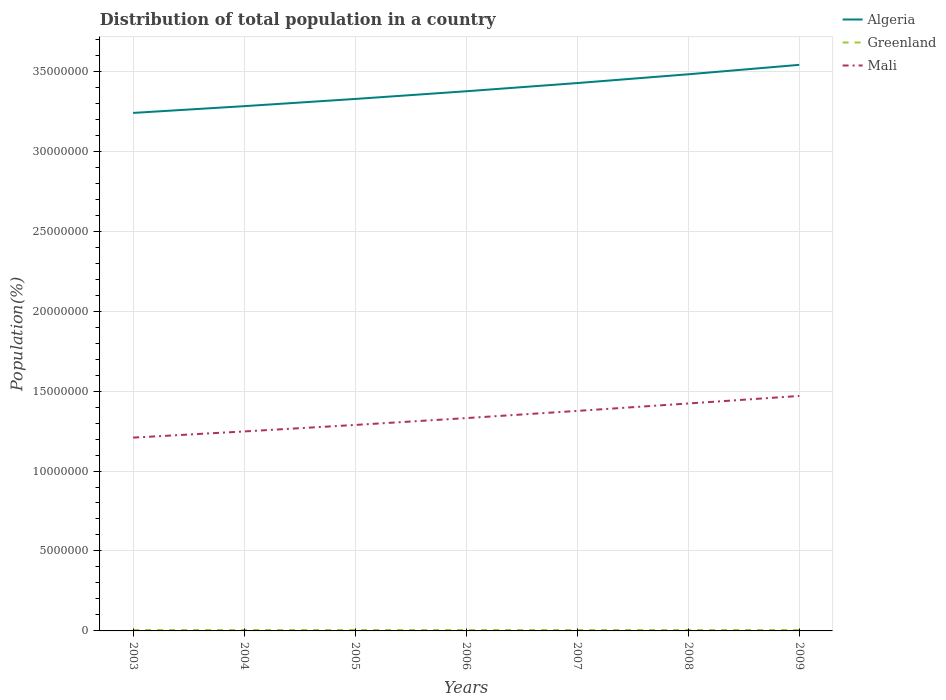How many different coloured lines are there?
Make the answer very short. 3. Is the number of lines equal to the number of legend labels?
Offer a terse response. Yes. Across all years, what is the maximum population of in Mali?
Ensure brevity in your answer.  1.21e+07. What is the total population of in Algeria in the graph?
Give a very brief answer. -1.35e+06. What is the difference between the highest and the second highest population of in Algeria?
Ensure brevity in your answer.  3.01e+06. What is the difference between the highest and the lowest population of in Greenland?
Make the answer very short. 4. How many lines are there?
Ensure brevity in your answer.  3. Are the values on the major ticks of Y-axis written in scientific E-notation?
Provide a succinct answer. No. Does the graph contain any zero values?
Offer a very short reply. No. Does the graph contain grids?
Give a very brief answer. Yes. Where does the legend appear in the graph?
Offer a very short reply. Top right. How are the legend labels stacked?
Your answer should be compact. Vertical. What is the title of the graph?
Make the answer very short. Distribution of total population in a country. What is the label or title of the X-axis?
Provide a succinct answer. Years. What is the label or title of the Y-axis?
Your answer should be very brief. Population(%). What is the Population(%) in Algeria in 2003?
Your answer should be compact. 3.24e+07. What is the Population(%) of Greenland in 2003?
Ensure brevity in your answer.  5.68e+04. What is the Population(%) in Mali in 2003?
Your answer should be very brief. 1.21e+07. What is the Population(%) in Algeria in 2004?
Keep it short and to the point. 3.28e+07. What is the Population(%) in Greenland in 2004?
Your response must be concise. 5.69e+04. What is the Population(%) of Mali in 2004?
Make the answer very short. 1.25e+07. What is the Population(%) of Algeria in 2005?
Provide a short and direct response. 3.33e+07. What is the Population(%) of Greenland in 2005?
Your answer should be compact. 5.69e+04. What is the Population(%) of Mali in 2005?
Offer a very short reply. 1.29e+07. What is the Population(%) in Algeria in 2006?
Make the answer very short. 3.37e+07. What is the Population(%) in Greenland in 2006?
Offer a very short reply. 5.68e+04. What is the Population(%) in Mali in 2006?
Give a very brief answer. 1.33e+07. What is the Population(%) of Algeria in 2007?
Give a very brief answer. 3.43e+07. What is the Population(%) of Greenland in 2007?
Provide a short and direct response. 5.66e+04. What is the Population(%) in Mali in 2007?
Provide a succinct answer. 1.38e+07. What is the Population(%) of Algeria in 2008?
Your answer should be compact. 3.48e+07. What is the Population(%) of Greenland in 2008?
Offer a very short reply. 5.63e+04. What is the Population(%) in Mali in 2008?
Your response must be concise. 1.42e+07. What is the Population(%) of Algeria in 2009?
Offer a terse response. 3.54e+07. What is the Population(%) of Greenland in 2009?
Your answer should be compact. 5.63e+04. What is the Population(%) in Mali in 2009?
Your answer should be very brief. 1.47e+07. Across all years, what is the maximum Population(%) of Algeria?
Your response must be concise. 3.54e+07. Across all years, what is the maximum Population(%) in Greenland?
Give a very brief answer. 5.69e+04. Across all years, what is the maximum Population(%) of Mali?
Give a very brief answer. 1.47e+07. Across all years, what is the minimum Population(%) in Algeria?
Offer a very short reply. 3.24e+07. Across all years, what is the minimum Population(%) in Greenland?
Keep it short and to the point. 5.63e+04. Across all years, what is the minimum Population(%) in Mali?
Keep it short and to the point. 1.21e+07. What is the total Population(%) in Algeria in the graph?
Your response must be concise. 2.37e+08. What is the total Population(%) in Greenland in the graph?
Make the answer very short. 3.97e+05. What is the total Population(%) of Mali in the graph?
Your answer should be very brief. 9.34e+07. What is the difference between the Population(%) in Algeria in 2003 and that in 2004?
Your response must be concise. -4.22e+05. What is the difference between the Population(%) of Greenland in 2003 and that in 2004?
Ensure brevity in your answer.  -146. What is the difference between the Population(%) of Mali in 2003 and that in 2004?
Your answer should be very brief. -3.86e+05. What is the difference between the Population(%) of Algeria in 2003 and that in 2005?
Keep it short and to the point. -8.73e+05. What is the difference between the Population(%) in Greenland in 2003 and that in 2005?
Provide a succinct answer. -170. What is the difference between the Population(%) in Mali in 2003 and that in 2005?
Provide a short and direct response. -7.93e+05. What is the difference between the Population(%) of Algeria in 2003 and that in 2006?
Provide a short and direct response. -1.35e+06. What is the difference between the Population(%) in Mali in 2003 and that in 2006?
Your response must be concise. -1.22e+06. What is the difference between the Population(%) in Algeria in 2003 and that in 2007?
Your answer should be compact. -1.87e+06. What is the difference between the Population(%) in Greenland in 2003 and that in 2007?
Offer a very short reply. 210. What is the difference between the Population(%) in Mali in 2003 and that in 2007?
Offer a very short reply. -1.67e+06. What is the difference between the Population(%) in Algeria in 2003 and that in 2008?
Ensure brevity in your answer.  -2.42e+06. What is the difference between the Population(%) in Greenland in 2003 and that in 2008?
Ensure brevity in your answer.  437. What is the difference between the Population(%) of Mali in 2003 and that in 2008?
Provide a succinct answer. -2.13e+06. What is the difference between the Population(%) of Algeria in 2003 and that in 2009?
Give a very brief answer. -3.01e+06. What is the difference between the Population(%) in Greenland in 2003 and that in 2009?
Make the answer very short. 442. What is the difference between the Population(%) of Mali in 2003 and that in 2009?
Offer a very short reply. -2.61e+06. What is the difference between the Population(%) of Algeria in 2004 and that in 2005?
Ensure brevity in your answer.  -4.51e+05. What is the difference between the Population(%) in Greenland in 2004 and that in 2005?
Provide a short and direct response. -24. What is the difference between the Population(%) in Mali in 2004 and that in 2005?
Provide a succinct answer. -4.07e+05. What is the difference between the Population(%) in Algeria in 2004 and that in 2006?
Make the answer very short. -9.32e+05. What is the difference between the Population(%) of Greenland in 2004 and that in 2006?
Make the answer very short. 137. What is the difference between the Population(%) of Mali in 2004 and that in 2006?
Provide a succinct answer. -8.35e+05. What is the difference between the Population(%) of Algeria in 2004 and that in 2007?
Ensure brevity in your answer.  -1.44e+06. What is the difference between the Population(%) of Greenland in 2004 and that in 2007?
Give a very brief answer. 356. What is the difference between the Population(%) in Mali in 2004 and that in 2007?
Offer a terse response. -1.28e+06. What is the difference between the Population(%) of Algeria in 2004 and that in 2008?
Provide a short and direct response. -1.99e+06. What is the difference between the Population(%) of Greenland in 2004 and that in 2008?
Make the answer very short. 583. What is the difference between the Population(%) in Mali in 2004 and that in 2008?
Make the answer very short. -1.75e+06. What is the difference between the Population(%) of Algeria in 2004 and that in 2009?
Ensure brevity in your answer.  -2.58e+06. What is the difference between the Population(%) of Greenland in 2004 and that in 2009?
Provide a short and direct response. 588. What is the difference between the Population(%) in Mali in 2004 and that in 2009?
Provide a succinct answer. -2.22e+06. What is the difference between the Population(%) in Algeria in 2005 and that in 2006?
Ensure brevity in your answer.  -4.81e+05. What is the difference between the Population(%) in Greenland in 2005 and that in 2006?
Provide a succinct answer. 161. What is the difference between the Population(%) of Mali in 2005 and that in 2006?
Give a very brief answer. -4.29e+05. What is the difference between the Population(%) in Algeria in 2005 and that in 2007?
Offer a very short reply. -9.94e+05. What is the difference between the Population(%) of Greenland in 2005 and that in 2007?
Your response must be concise. 380. What is the difference between the Population(%) in Mali in 2005 and that in 2007?
Provide a succinct answer. -8.78e+05. What is the difference between the Population(%) of Algeria in 2005 and that in 2008?
Offer a terse response. -1.54e+06. What is the difference between the Population(%) in Greenland in 2005 and that in 2008?
Give a very brief answer. 607. What is the difference between the Population(%) in Mali in 2005 and that in 2008?
Offer a terse response. -1.34e+06. What is the difference between the Population(%) of Algeria in 2005 and that in 2009?
Your answer should be compact. -2.13e+06. What is the difference between the Population(%) of Greenland in 2005 and that in 2009?
Offer a terse response. 612. What is the difference between the Population(%) of Mali in 2005 and that in 2009?
Make the answer very short. -1.81e+06. What is the difference between the Population(%) of Algeria in 2006 and that in 2007?
Your answer should be compact. -5.13e+05. What is the difference between the Population(%) in Greenland in 2006 and that in 2007?
Offer a very short reply. 219. What is the difference between the Population(%) of Mali in 2006 and that in 2007?
Make the answer very short. -4.49e+05. What is the difference between the Population(%) of Algeria in 2006 and that in 2008?
Offer a very short reply. -1.06e+06. What is the difference between the Population(%) in Greenland in 2006 and that in 2008?
Provide a succinct answer. 446. What is the difference between the Population(%) in Mali in 2006 and that in 2008?
Your response must be concise. -9.13e+05. What is the difference between the Population(%) of Algeria in 2006 and that in 2009?
Make the answer very short. -1.65e+06. What is the difference between the Population(%) in Greenland in 2006 and that in 2009?
Offer a terse response. 451. What is the difference between the Population(%) of Mali in 2006 and that in 2009?
Offer a very short reply. -1.38e+06. What is the difference between the Population(%) of Algeria in 2007 and that in 2008?
Offer a terse response. -5.49e+05. What is the difference between the Population(%) of Greenland in 2007 and that in 2008?
Give a very brief answer. 227. What is the difference between the Population(%) in Mali in 2007 and that in 2008?
Ensure brevity in your answer.  -4.64e+05. What is the difference between the Population(%) of Algeria in 2007 and that in 2009?
Offer a terse response. -1.14e+06. What is the difference between the Population(%) of Greenland in 2007 and that in 2009?
Your answer should be very brief. 232. What is the difference between the Population(%) of Mali in 2007 and that in 2009?
Offer a terse response. -9.35e+05. What is the difference between the Population(%) of Algeria in 2008 and that in 2009?
Provide a short and direct response. -5.91e+05. What is the difference between the Population(%) of Mali in 2008 and that in 2009?
Provide a succinct answer. -4.71e+05. What is the difference between the Population(%) of Algeria in 2003 and the Population(%) of Greenland in 2004?
Keep it short and to the point. 3.23e+07. What is the difference between the Population(%) of Algeria in 2003 and the Population(%) of Mali in 2004?
Keep it short and to the point. 1.99e+07. What is the difference between the Population(%) in Greenland in 2003 and the Population(%) in Mali in 2004?
Your answer should be compact. -1.24e+07. What is the difference between the Population(%) of Algeria in 2003 and the Population(%) of Greenland in 2005?
Keep it short and to the point. 3.23e+07. What is the difference between the Population(%) of Algeria in 2003 and the Population(%) of Mali in 2005?
Keep it short and to the point. 1.95e+07. What is the difference between the Population(%) in Greenland in 2003 and the Population(%) in Mali in 2005?
Make the answer very short. -1.28e+07. What is the difference between the Population(%) of Algeria in 2003 and the Population(%) of Greenland in 2006?
Make the answer very short. 3.23e+07. What is the difference between the Population(%) in Algeria in 2003 and the Population(%) in Mali in 2006?
Offer a very short reply. 1.91e+07. What is the difference between the Population(%) of Greenland in 2003 and the Population(%) of Mali in 2006?
Provide a short and direct response. -1.33e+07. What is the difference between the Population(%) of Algeria in 2003 and the Population(%) of Greenland in 2007?
Keep it short and to the point. 3.23e+07. What is the difference between the Population(%) in Algeria in 2003 and the Population(%) in Mali in 2007?
Provide a short and direct response. 1.86e+07. What is the difference between the Population(%) in Greenland in 2003 and the Population(%) in Mali in 2007?
Make the answer very short. -1.37e+07. What is the difference between the Population(%) of Algeria in 2003 and the Population(%) of Greenland in 2008?
Provide a succinct answer. 3.23e+07. What is the difference between the Population(%) in Algeria in 2003 and the Population(%) in Mali in 2008?
Your response must be concise. 1.82e+07. What is the difference between the Population(%) of Greenland in 2003 and the Population(%) of Mali in 2008?
Your response must be concise. -1.42e+07. What is the difference between the Population(%) of Algeria in 2003 and the Population(%) of Greenland in 2009?
Ensure brevity in your answer.  3.23e+07. What is the difference between the Population(%) of Algeria in 2003 and the Population(%) of Mali in 2009?
Give a very brief answer. 1.77e+07. What is the difference between the Population(%) of Greenland in 2003 and the Population(%) of Mali in 2009?
Ensure brevity in your answer.  -1.46e+07. What is the difference between the Population(%) in Algeria in 2004 and the Population(%) in Greenland in 2005?
Your response must be concise. 3.28e+07. What is the difference between the Population(%) of Algeria in 2004 and the Population(%) of Mali in 2005?
Your answer should be compact. 1.99e+07. What is the difference between the Population(%) in Greenland in 2004 and the Population(%) in Mali in 2005?
Offer a very short reply. -1.28e+07. What is the difference between the Population(%) in Algeria in 2004 and the Population(%) in Greenland in 2006?
Your response must be concise. 3.28e+07. What is the difference between the Population(%) of Algeria in 2004 and the Population(%) of Mali in 2006?
Your response must be concise. 1.95e+07. What is the difference between the Population(%) in Greenland in 2004 and the Population(%) in Mali in 2006?
Offer a terse response. -1.33e+07. What is the difference between the Population(%) in Algeria in 2004 and the Population(%) in Greenland in 2007?
Keep it short and to the point. 3.28e+07. What is the difference between the Population(%) in Algeria in 2004 and the Population(%) in Mali in 2007?
Your response must be concise. 1.91e+07. What is the difference between the Population(%) in Greenland in 2004 and the Population(%) in Mali in 2007?
Your answer should be compact. -1.37e+07. What is the difference between the Population(%) of Algeria in 2004 and the Population(%) of Greenland in 2008?
Offer a very short reply. 3.28e+07. What is the difference between the Population(%) in Algeria in 2004 and the Population(%) in Mali in 2008?
Provide a short and direct response. 1.86e+07. What is the difference between the Population(%) of Greenland in 2004 and the Population(%) of Mali in 2008?
Provide a succinct answer. -1.42e+07. What is the difference between the Population(%) in Algeria in 2004 and the Population(%) in Greenland in 2009?
Your answer should be very brief. 3.28e+07. What is the difference between the Population(%) of Algeria in 2004 and the Population(%) of Mali in 2009?
Your answer should be compact. 1.81e+07. What is the difference between the Population(%) in Greenland in 2004 and the Population(%) in Mali in 2009?
Give a very brief answer. -1.46e+07. What is the difference between the Population(%) in Algeria in 2005 and the Population(%) in Greenland in 2006?
Provide a short and direct response. 3.32e+07. What is the difference between the Population(%) in Algeria in 2005 and the Population(%) in Mali in 2006?
Your answer should be compact. 2.00e+07. What is the difference between the Population(%) of Greenland in 2005 and the Population(%) of Mali in 2006?
Ensure brevity in your answer.  -1.33e+07. What is the difference between the Population(%) of Algeria in 2005 and the Population(%) of Greenland in 2007?
Give a very brief answer. 3.32e+07. What is the difference between the Population(%) in Algeria in 2005 and the Population(%) in Mali in 2007?
Offer a terse response. 1.95e+07. What is the difference between the Population(%) in Greenland in 2005 and the Population(%) in Mali in 2007?
Ensure brevity in your answer.  -1.37e+07. What is the difference between the Population(%) of Algeria in 2005 and the Population(%) of Greenland in 2008?
Your answer should be compact. 3.32e+07. What is the difference between the Population(%) of Algeria in 2005 and the Population(%) of Mali in 2008?
Make the answer very short. 1.90e+07. What is the difference between the Population(%) in Greenland in 2005 and the Population(%) in Mali in 2008?
Your response must be concise. -1.42e+07. What is the difference between the Population(%) of Algeria in 2005 and the Population(%) of Greenland in 2009?
Offer a terse response. 3.32e+07. What is the difference between the Population(%) in Algeria in 2005 and the Population(%) in Mali in 2009?
Your answer should be compact. 1.86e+07. What is the difference between the Population(%) of Greenland in 2005 and the Population(%) of Mali in 2009?
Your response must be concise. -1.46e+07. What is the difference between the Population(%) of Algeria in 2006 and the Population(%) of Greenland in 2007?
Make the answer very short. 3.37e+07. What is the difference between the Population(%) in Algeria in 2006 and the Population(%) in Mali in 2007?
Keep it short and to the point. 2.00e+07. What is the difference between the Population(%) in Greenland in 2006 and the Population(%) in Mali in 2007?
Ensure brevity in your answer.  -1.37e+07. What is the difference between the Population(%) of Algeria in 2006 and the Population(%) of Greenland in 2008?
Offer a very short reply. 3.37e+07. What is the difference between the Population(%) in Algeria in 2006 and the Population(%) in Mali in 2008?
Keep it short and to the point. 1.95e+07. What is the difference between the Population(%) of Greenland in 2006 and the Population(%) of Mali in 2008?
Provide a succinct answer. -1.42e+07. What is the difference between the Population(%) of Algeria in 2006 and the Population(%) of Greenland in 2009?
Your answer should be compact. 3.37e+07. What is the difference between the Population(%) of Algeria in 2006 and the Population(%) of Mali in 2009?
Keep it short and to the point. 1.91e+07. What is the difference between the Population(%) in Greenland in 2006 and the Population(%) in Mali in 2009?
Give a very brief answer. -1.46e+07. What is the difference between the Population(%) of Algeria in 2007 and the Population(%) of Greenland in 2008?
Your answer should be compact. 3.42e+07. What is the difference between the Population(%) in Algeria in 2007 and the Population(%) in Mali in 2008?
Provide a short and direct response. 2.00e+07. What is the difference between the Population(%) in Greenland in 2007 and the Population(%) in Mali in 2008?
Offer a very short reply. -1.42e+07. What is the difference between the Population(%) in Algeria in 2007 and the Population(%) in Greenland in 2009?
Your answer should be very brief. 3.42e+07. What is the difference between the Population(%) of Algeria in 2007 and the Population(%) of Mali in 2009?
Ensure brevity in your answer.  1.96e+07. What is the difference between the Population(%) in Greenland in 2007 and the Population(%) in Mali in 2009?
Your answer should be compact. -1.46e+07. What is the difference between the Population(%) of Algeria in 2008 and the Population(%) of Greenland in 2009?
Offer a terse response. 3.48e+07. What is the difference between the Population(%) in Algeria in 2008 and the Population(%) in Mali in 2009?
Your response must be concise. 2.01e+07. What is the difference between the Population(%) of Greenland in 2008 and the Population(%) of Mali in 2009?
Give a very brief answer. -1.46e+07. What is the average Population(%) of Algeria per year?
Offer a very short reply. 3.38e+07. What is the average Population(%) in Greenland per year?
Your response must be concise. 5.67e+04. What is the average Population(%) of Mali per year?
Your answer should be compact. 1.33e+07. In the year 2003, what is the difference between the Population(%) in Algeria and Population(%) in Greenland?
Ensure brevity in your answer.  3.23e+07. In the year 2003, what is the difference between the Population(%) in Algeria and Population(%) in Mali?
Your answer should be very brief. 2.03e+07. In the year 2003, what is the difference between the Population(%) of Greenland and Population(%) of Mali?
Keep it short and to the point. -1.20e+07. In the year 2004, what is the difference between the Population(%) in Algeria and Population(%) in Greenland?
Provide a succinct answer. 3.28e+07. In the year 2004, what is the difference between the Population(%) of Algeria and Population(%) of Mali?
Your answer should be compact. 2.03e+07. In the year 2004, what is the difference between the Population(%) of Greenland and Population(%) of Mali?
Offer a very short reply. -1.24e+07. In the year 2005, what is the difference between the Population(%) in Algeria and Population(%) in Greenland?
Your answer should be compact. 3.32e+07. In the year 2005, what is the difference between the Population(%) in Algeria and Population(%) in Mali?
Your answer should be very brief. 2.04e+07. In the year 2005, what is the difference between the Population(%) of Greenland and Population(%) of Mali?
Ensure brevity in your answer.  -1.28e+07. In the year 2006, what is the difference between the Population(%) of Algeria and Population(%) of Greenland?
Offer a terse response. 3.37e+07. In the year 2006, what is the difference between the Population(%) in Algeria and Population(%) in Mali?
Make the answer very short. 2.04e+07. In the year 2006, what is the difference between the Population(%) of Greenland and Population(%) of Mali?
Give a very brief answer. -1.33e+07. In the year 2007, what is the difference between the Population(%) in Algeria and Population(%) in Greenland?
Your answer should be very brief. 3.42e+07. In the year 2007, what is the difference between the Population(%) in Algeria and Population(%) in Mali?
Your response must be concise. 2.05e+07. In the year 2007, what is the difference between the Population(%) of Greenland and Population(%) of Mali?
Your answer should be compact. -1.37e+07. In the year 2008, what is the difference between the Population(%) of Algeria and Population(%) of Greenland?
Your answer should be very brief. 3.48e+07. In the year 2008, what is the difference between the Population(%) in Algeria and Population(%) in Mali?
Give a very brief answer. 2.06e+07. In the year 2008, what is the difference between the Population(%) in Greenland and Population(%) in Mali?
Your answer should be compact. -1.42e+07. In the year 2009, what is the difference between the Population(%) of Algeria and Population(%) of Greenland?
Make the answer very short. 3.53e+07. In the year 2009, what is the difference between the Population(%) of Algeria and Population(%) of Mali?
Keep it short and to the point. 2.07e+07. In the year 2009, what is the difference between the Population(%) in Greenland and Population(%) in Mali?
Offer a very short reply. -1.46e+07. What is the ratio of the Population(%) in Algeria in 2003 to that in 2004?
Keep it short and to the point. 0.99. What is the ratio of the Population(%) in Mali in 2003 to that in 2004?
Your answer should be compact. 0.97. What is the ratio of the Population(%) of Algeria in 2003 to that in 2005?
Offer a very short reply. 0.97. What is the ratio of the Population(%) of Mali in 2003 to that in 2005?
Keep it short and to the point. 0.94. What is the ratio of the Population(%) of Algeria in 2003 to that in 2006?
Your answer should be very brief. 0.96. What is the ratio of the Population(%) in Greenland in 2003 to that in 2006?
Your answer should be compact. 1. What is the ratio of the Population(%) of Mali in 2003 to that in 2006?
Offer a terse response. 0.91. What is the ratio of the Population(%) of Algeria in 2003 to that in 2007?
Your response must be concise. 0.95. What is the ratio of the Population(%) of Greenland in 2003 to that in 2007?
Offer a very short reply. 1. What is the ratio of the Population(%) in Mali in 2003 to that in 2007?
Provide a short and direct response. 0.88. What is the ratio of the Population(%) of Algeria in 2003 to that in 2008?
Offer a terse response. 0.93. What is the ratio of the Population(%) of Greenland in 2003 to that in 2008?
Make the answer very short. 1.01. What is the ratio of the Population(%) of Mali in 2003 to that in 2008?
Make the answer very short. 0.85. What is the ratio of the Population(%) in Algeria in 2003 to that in 2009?
Give a very brief answer. 0.92. What is the ratio of the Population(%) of Mali in 2003 to that in 2009?
Make the answer very short. 0.82. What is the ratio of the Population(%) in Algeria in 2004 to that in 2005?
Offer a terse response. 0.99. What is the ratio of the Population(%) of Mali in 2004 to that in 2005?
Make the answer very short. 0.97. What is the ratio of the Population(%) of Algeria in 2004 to that in 2006?
Your answer should be compact. 0.97. What is the ratio of the Population(%) in Greenland in 2004 to that in 2006?
Give a very brief answer. 1. What is the ratio of the Population(%) of Mali in 2004 to that in 2006?
Offer a very short reply. 0.94. What is the ratio of the Population(%) in Algeria in 2004 to that in 2007?
Ensure brevity in your answer.  0.96. What is the ratio of the Population(%) of Greenland in 2004 to that in 2007?
Offer a very short reply. 1.01. What is the ratio of the Population(%) in Mali in 2004 to that in 2007?
Provide a short and direct response. 0.91. What is the ratio of the Population(%) in Algeria in 2004 to that in 2008?
Your response must be concise. 0.94. What is the ratio of the Population(%) in Greenland in 2004 to that in 2008?
Make the answer very short. 1.01. What is the ratio of the Population(%) in Mali in 2004 to that in 2008?
Ensure brevity in your answer.  0.88. What is the ratio of the Population(%) of Algeria in 2004 to that in 2009?
Your answer should be very brief. 0.93. What is the ratio of the Population(%) of Greenland in 2004 to that in 2009?
Make the answer very short. 1.01. What is the ratio of the Population(%) in Mali in 2004 to that in 2009?
Provide a short and direct response. 0.85. What is the ratio of the Population(%) of Algeria in 2005 to that in 2006?
Provide a succinct answer. 0.99. What is the ratio of the Population(%) of Greenland in 2005 to that in 2006?
Your response must be concise. 1. What is the ratio of the Population(%) of Mali in 2005 to that in 2006?
Give a very brief answer. 0.97. What is the ratio of the Population(%) of Greenland in 2005 to that in 2007?
Keep it short and to the point. 1.01. What is the ratio of the Population(%) in Mali in 2005 to that in 2007?
Offer a terse response. 0.94. What is the ratio of the Population(%) in Algeria in 2005 to that in 2008?
Make the answer very short. 0.96. What is the ratio of the Population(%) of Greenland in 2005 to that in 2008?
Offer a terse response. 1.01. What is the ratio of the Population(%) of Mali in 2005 to that in 2008?
Your answer should be compact. 0.91. What is the ratio of the Population(%) in Algeria in 2005 to that in 2009?
Give a very brief answer. 0.94. What is the ratio of the Population(%) of Greenland in 2005 to that in 2009?
Offer a very short reply. 1.01. What is the ratio of the Population(%) of Mali in 2005 to that in 2009?
Provide a short and direct response. 0.88. What is the ratio of the Population(%) in Algeria in 2006 to that in 2007?
Offer a very short reply. 0.98. What is the ratio of the Population(%) in Greenland in 2006 to that in 2007?
Your response must be concise. 1. What is the ratio of the Population(%) in Mali in 2006 to that in 2007?
Your answer should be compact. 0.97. What is the ratio of the Population(%) in Algeria in 2006 to that in 2008?
Your response must be concise. 0.97. What is the ratio of the Population(%) in Greenland in 2006 to that in 2008?
Ensure brevity in your answer.  1.01. What is the ratio of the Population(%) in Mali in 2006 to that in 2008?
Offer a terse response. 0.94. What is the ratio of the Population(%) in Algeria in 2006 to that in 2009?
Make the answer very short. 0.95. What is the ratio of the Population(%) of Mali in 2006 to that in 2009?
Your answer should be very brief. 0.91. What is the ratio of the Population(%) of Algeria in 2007 to that in 2008?
Offer a terse response. 0.98. What is the ratio of the Population(%) in Mali in 2007 to that in 2008?
Give a very brief answer. 0.97. What is the ratio of the Population(%) of Algeria in 2007 to that in 2009?
Keep it short and to the point. 0.97. What is the ratio of the Population(%) in Greenland in 2007 to that in 2009?
Your answer should be compact. 1. What is the ratio of the Population(%) in Mali in 2007 to that in 2009?
Ensure brevity in your answer.  0.94. What is the ratio of the Population(%) of Algeria in 2008 to that in 2009?
Provide a short and direct response. 0.98. What is the ratio of the Population(%) of Greenland in 2008 to that in 2009?
Offer a very short reply. 1. What is the ratio of the Population(%) in Mali in 2008 to that in 2009?
Provide a short and direct response. 0.97. What is the difference between the highest and the second highest Population(%) in Algeria?
Provide a short and direct response. 5.91e+05. What is the difference between the highest and the second highest Population(%) in Mali?
Provide a succinct answer. 4.71e+05. What is the difference between the highest and the lowest Population(%) of Algeria?
Ensure brevity in your answer.  3.01e+06. What is the difference between the highest and the lowest Population(%) in Greenland?
Provide a succinct answer. 612. What is the difference between the highest and the lowest Population(%) of Mali?
Provide a succinct answer. 2.61e+06. 